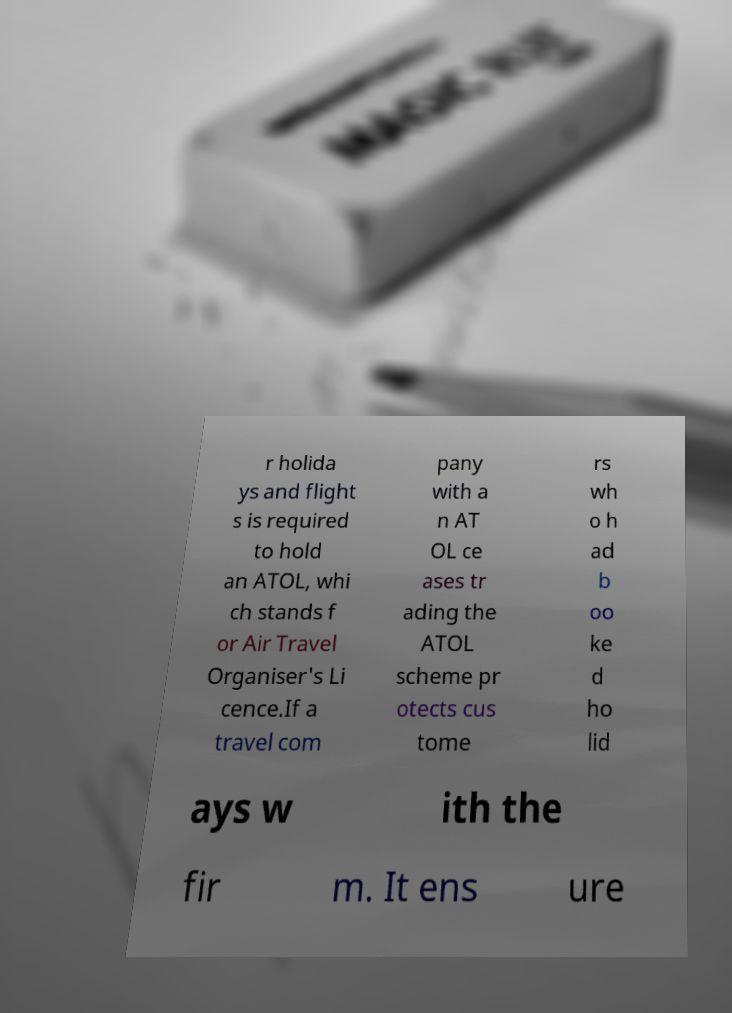What messages or text are displayed in this image? I need them in a readable, typed format. r holida ys and flight s is required to hold an ATOL, whi ch stands f or Air Travel Organiser's Li cence.If a travel com pany with a n AT OL ce ases tr ading the ATOL scheme pr otects cus tome rs wh o h ad b oo ke d ho lid ays w ith the fir m. It ens ure 